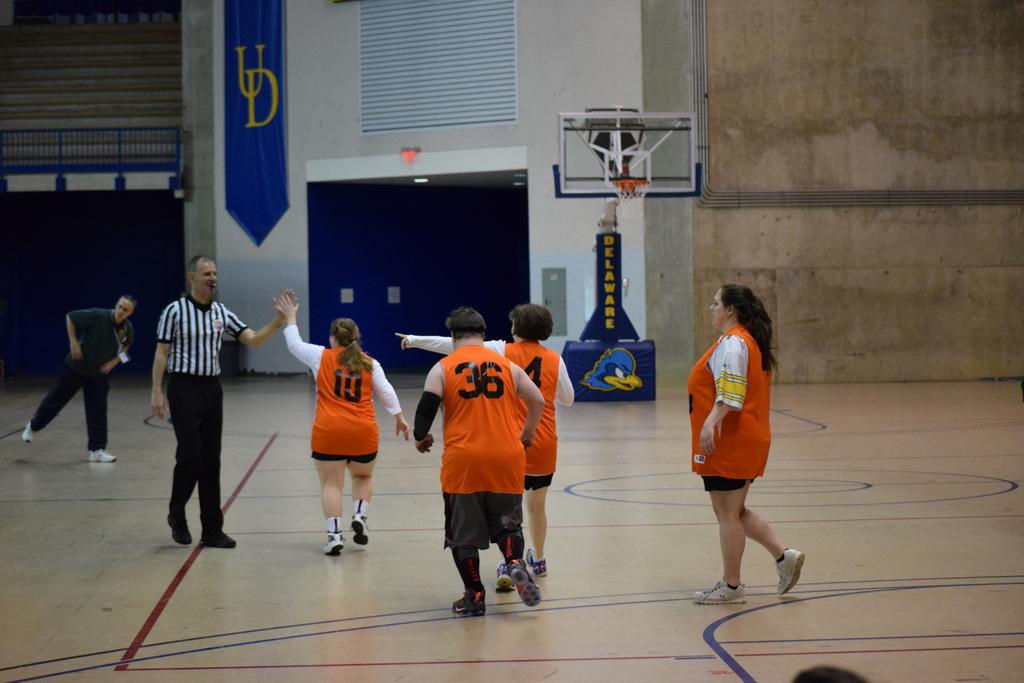Could you give a brief overview of what you see in this image? In this picture we can see few people on the ground and in the background we can see a wall, basketball hoop and some objects. 